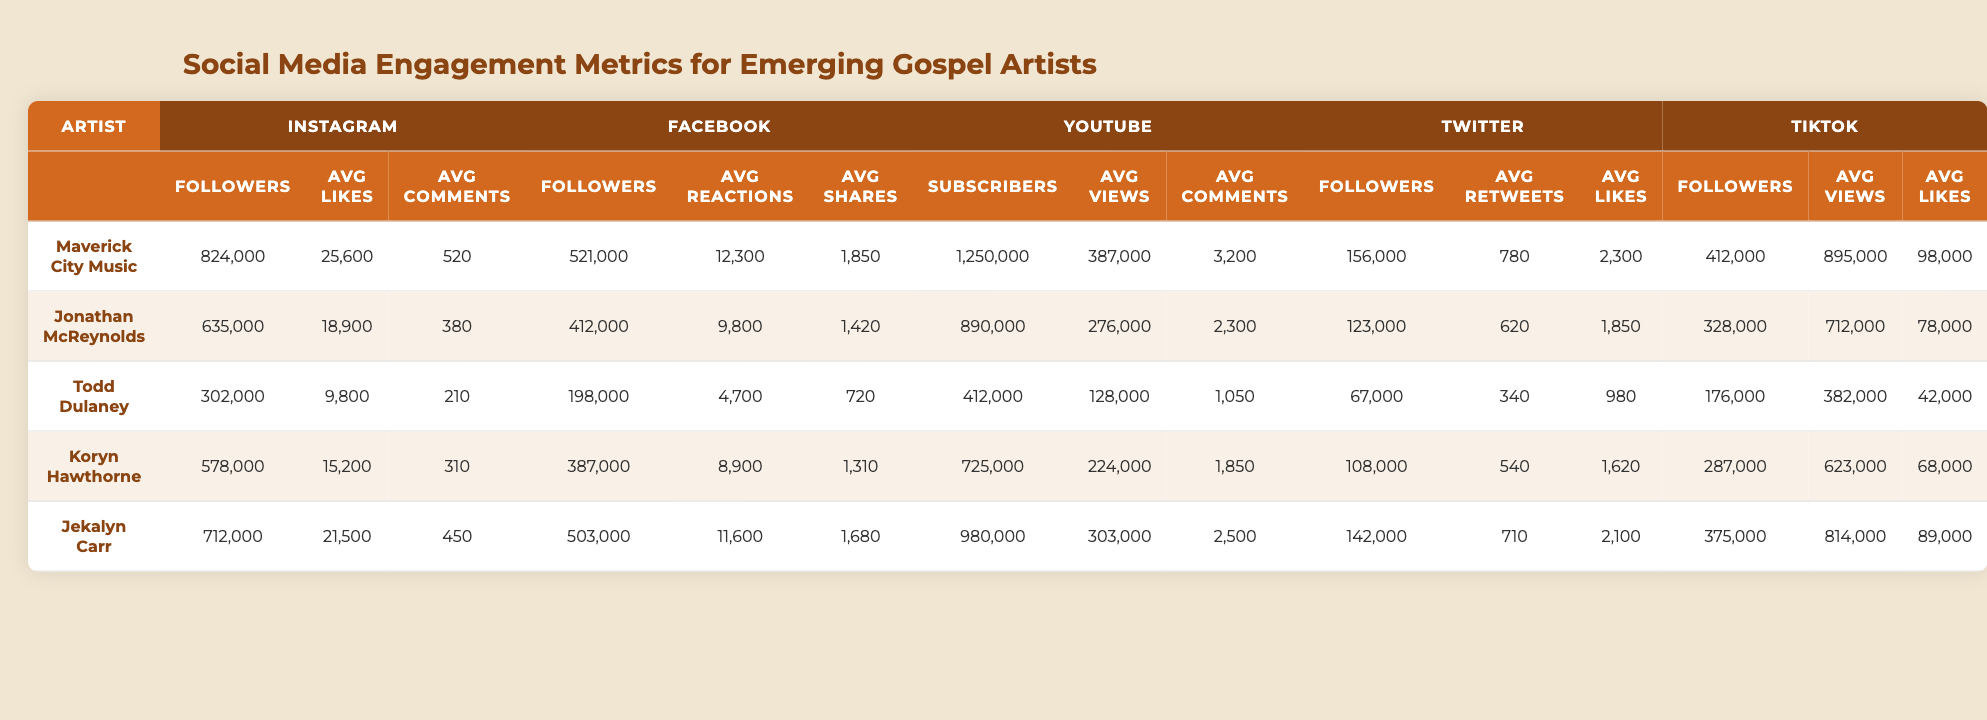What is the highest number of Instagram followers among the listed artists? By looking at the 'Instagram_Followers' column, I see that Maverick City Music has 824,000 followers, which is the highest number compared to the other artists listed.
Answer: 824,000 Which artist has the lowest average number of YouTube views? In the 'YouTube_Avg_Views' column, Todd Dulaney has the lowest average views with 128,000.
Answer: 128,000 What is the total number of Facebook followers for all artists combined? I sum the values in the 'Facebook_Followers' column: 521,000 + 412,000 + 198,000 + 387,000 + 503,000 = 2,021,000.
Answer: 2,021,000 Which artist has the highest average likes on TikTok? Looking at the 'TikTok_Avg_Likes' column, Maverick City Music has the highest average likes with 98,000, which is more than the others.
Answer: 98,000 Is it true that Koryn Hawthorne has more YouTube subscribers than Jonathan McReynolds? Comparing the values in the 'YouTube_Subscribers' column, Koryn Hawthorne has 725,000, and Jonathan McReynolds has 890,000. Since 725,000 is less than 890,000, the statement is false.
Answer: No What is the average number of average comments on Instagram across all artists? I add the 'Instagram_Avg_Comments' values (520 + 380 + 210 + 310 + 450 = 1870) and divide by 5 (the number of artists), giving 1870/5 = 374.
Answer: 374 Which social media platform has the highest average views for Koryn Hawthorne? Comparing the average views for Koryn Hawthorne, the values are: Instagram (15,200), Facebook (8,900), YouTube (224,000), Twitter (540), TikTok (623,000). The highest is TikTok with 623,000 average views.
Answer: TikTok How many more average likes does Jonathan McReynolds have on Instagram compared to Facebook? Jonathan's average likes on Instagram is 18,900, and on Facebook, it is 9,800. The difference is calculated as 18,900 - 9,800 = 9,100.
Answer: 9,100 What is the median number of Twitter followers among the artists? Listing the 'Twitter_Followers' values in ascending order: 67,000; 108,000; 123,000; 142,000; 156,000. The median is the middle value, which is 123,000.
Answer: 123,000 Who has the highest average reactions on Facebook? Checking the 'Facebook_Avg_Reactions' column, Maverick City Music has 12,300, which is higher than the others.
Answer: Maverick City Music 